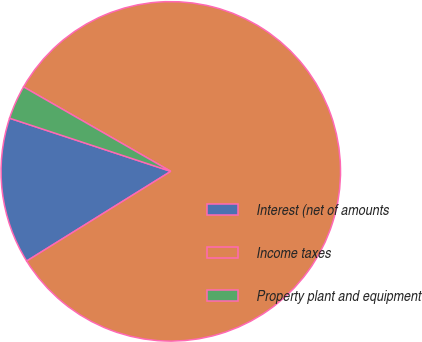Convert chart. <chart><loc_0><loc_0><loc_500><loc_500><pie_chart><fcel>Interest (net of amounts<fcel>Income taxes<fcel>Property plant and equipment<nl><fcel>13.93%<fcel>82.85%<fcel>3.22%<nl></chart> 